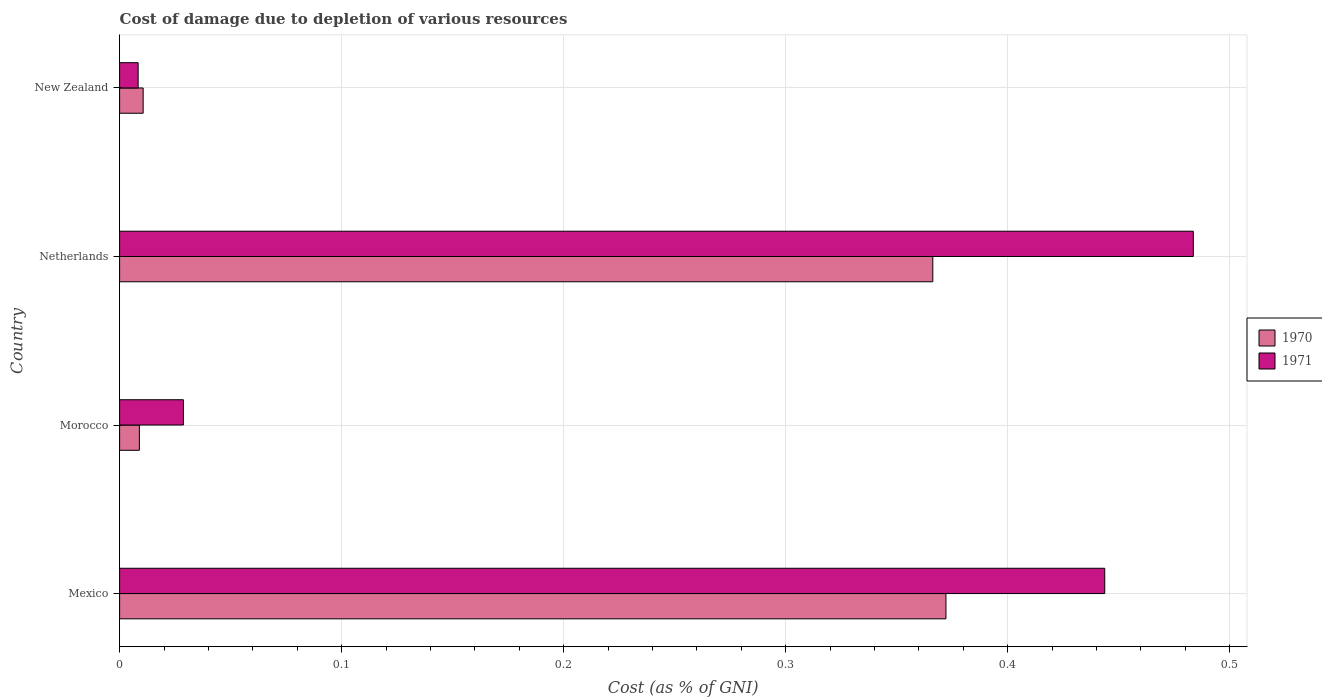How many different coloured bars are there?
Give a very brief answer. 2. How many groups of bars are there?
Provide a short and direct response. 4. Are the number of bars per tick equal to the number of legend labels?
Your answer should be very brief. Yes. Are the number of bars on each tick of the Y-axis equal?
Give a very brief answer. Yes. How many bars are there on the 1st tick from the bottom?
Give a very brief answer. 2. What is the cost of damage caused due to the depletion of various resources in 1971 in Netherlands?
Make the answer very short. 0.48. Across all countries, what is the maximum cost of damage caused due to the depletion of various resources in 1971?
Your answer should be very brief. 0.48. Across all countries, what is the minimum cost of damage caused due to the depletion of various resources in 1971?
Your answer should be compact. 0.01. In which country was the cost of damage caused due to the depletion of various resources in 1970 maximum?
Keep it short and to the point. Mexico. In which country was the cost of damage caused due to the depletion of various resources in 1970 minimum?
Offer a very short reply. Morocco. What is the total cost of damage caused due to the depletion of various resources in 1971 in the graph?
Provide a short and direct response. 0.96. What is the difference between the cost of damage caused due to the depletion of various resources in 1971 in Mexico and that in Netherlands?
Keep it short and to the point. -0.04. What is the difference between the cost of damage caused due to the depletion of various resources in 1970 in New Zealand and the cost of damage caused due to the depletion of various resources in 1971 in Morocco?
Provide a short and direct response. -0.02. What is the average cost of damage caused due to the depletion of various resources in 1970 per country?
Provide a short and direct response. 0.19. What is the difference between the cost of damage caused due to the depletion of various resources in 1971 and cost of damage caused due to the depletion of various resources in 1970 in New Zealand?
Your response must be concise. -0. In how many countries, is the cost of damage caused due to the depletion of various resources in 1970 greater than 0.34 %?
Offer a very short reply. 2. What is the ratio of the cost of damage caused due to the depletion of various resources in 1971 in Morocco to that in New Zealand?
Make the answer very short. 3.44. What is the difference between the highest and the second highest cost of damage caused due to the depletion of various resources in 1971?
Give a very brief answer. 0.04. What is the difference between the highest and the lowest cost of damage caused due to the depletion of various resources in 1971?
Your answer should be very brief. 0.48. In how many countries, is the cost of damage caused due to the depletion of various resources in 1971 greater than the average cost of damage caused due to the depletion of various resources in 1971 taken over all countries?
Provide a short and direct response. 2. Is the sum of the cost of damage caused due to the depletion of various resources in 1971 in Mexico and New Zealand greater than the maximum cost of damage caused due to the depletion of various resources in 1970 across all countries?
Your answer should be compact. Yes. What does the 1st bar from the bottom in New Zealand represents?
Provide a succinct answer. 1970. Are all the bars in the graph horizontal?
Your answer should be compact. Yes. How many countries are there in the graph?
Provide a short and direct response. 4. Are the values on the major ticks of X-axis written in scientific E-notation?
Your response must be concise. No. How many legend labels are there?
Ensure brevity in your answer.  2. What is the title of the graph?
Offer a terse response. Cost of damage due to depletion of various resources. Does "2010" appear as one of the legend labels in the graph?
Ensure brevity in your answer.  No. What is the label or title of the X-axis?
Your response must be concise. Cost (as % of GNI). What is the label or title of the Y-axis?
Offer a terse response. Country. What is the Cost (as % of GNI) in 1970 in Mexico?
Your answer should be very brief. 0.37. What is the Cost (as % of GNI) in 1971 in Mexico?
Ensure brevity in your answer.  0.44. What is the Cost (as % of GNI) of 1970 in Morocco?
Provide a succinct answer. 0.01. What is the Cost (as % of GNI) in 1971 in Morocco?
Your response must be concise. 0.03. What is the Cost (as % of GNI) of 1970 in Netherlands?
Offer a terse response. 0.37. What is the Cost (as % of GNI) in 1971 in Netherlands?
Make the answer very short. 0.48. What is the Cost (as % of GNI) in 1970 in New Zealand?
Ensure brevity in your answer.  0.01. What is the Cost (as % of GNI) of 1971 in New Zealand?
Provide a short and direct response. 0.01. Across all countries, what is the maximum Cost (as % of GNI) in 1970?
Make the answer very short. 0.37. Across all countries, what is the maximum Cost (as % of GNI) in 1971?
Give a very brief answer. 0.48. Across all countries, what is the minimum Cost (as % of GNI) in 1970?
Provide a succinct answer. 0.01. Across all countries, what is the minimum Cost (as % of GNI) in 1971?
Offer a terse response. 0.01. What is the total Cost (as % of GNI) in 1970 in the graph?
Your response must be concise. 0.76. What is the total Cost (as % of GNI) in 1971 in the graph?
Provide a succinct answer. 0.96. What is the difference between the Cost (as % of GNI) in 1970 in Mexico and that in Morocco?
Your answer should be compact. 0.36. What is the difference between the Cost (as % of GNI) of 1971 in Mexico and that in Morocco?
Your answer should be compact. 0.41. What is the difference between the Cost (as % of GNI) of 1970 in Mexico and that in Netherlands?
Your response must be concise. 0.01. What is the difference between the Cost (as % of GNI) of 1971 in Mexico and that in Netherlands?
Ensure brevity in your answer.  -0.04. What is the difference between the Cost (as % of GNI) of 1970 in Mexico and that in New Zealand?
Your answer should be very brief. 0.36. What is the difference between the Cost (as % of GNI) of 1971 in Mexico and that in New Zealand?
Provide a short and direct response. 0.44. What is the difference between the Cost (as % of GNI) of 1970 in Morocco and that in Netherlands?
Make the answer very short. -0.36. What is the difference between the Cost (as % of GNI) in 1971 in Morocco and that in Netherlands?
Your answer should be compact. -0.45. What is the difference between the Cost (as % of GNI) in 1970 in Morocco and that in New Zealand?
Ensure brevity in your answer.  -0. What is the difference between the Cost (as % of GNI) of 1971 in Morocco and that in New Zealand?
Your answer should be very brief. 0.02. What is the difference between the Cost (as % of GNI) of 1970 in Netherlands and that in New Zealand?
Offer a terse response. 0.36. What is the difference between the Cost (as % of GNI) of 1971 in Netherlands and that in New Zealand?
Your response must be concise. 0.48. What is the difference between the Cost (as % of GNI) in 1970 in Mexico and the Cost (as % of GNI) in 1971 in Morocco?
Give a very brief answer. 0.34. What is the difference between the Cost (as % of GNI) in 1970 in Mexico and the Cost (as % of GNI) in 1971 in Netherlands?
Provide a short and direct response. -0.11. What is the difference between the Cost (as % of GNI) in 1970 in Mexico and the Cost (as % of GNI) in 1971 in New Zealand?
Offer a very short reply. 0.36. What is the difference between the Cost (as % of GNI) in 1970 in Morocco and the Cost (as % of GNI) in 1971 in Netherlands?
Provide a short and direct response. -0.47. What is the difference between the Cost (as % of GNI) of 1970 in Morocco and the Cost (as % of GNI) of 1971 in New Zealand?
Your answer should be compact. 0. What is the difference between the Cost (as % of GNI) of 1970 in Netherlands and the Cost (as % of GNI) of 1971 in New Zealand?
Ensure brevity in your answer.  0.36. What is the average Cost (as % of GNI) of 1970 per country?
Your answer should be very brief. 0.19. What is the average Cost (as % of GNI) in 1971 per country?
Provide a short and direct response. 0.24. What is the difference between the Cost (as % of GNI) of 1970 and Cost (as % of GNI) of 1971 in Mexico?
Your response must be concise. -0.07. What is the difference between the Cost (as % of GNI) of 1970 and Cost (as % of GNI) of 1971 in Morocco?
Provide a short and direct response. -0.02. What is the difference between the Cost (as % of GNI) of 1970 and Cost (as % of GNI) of 1971 in Netherlands?
Give a very brief answer. -0.12. What is the difference between the Cost (as % of GNI) in 1970 and Cost (as % of GNI) in 1971 in New Zealand?
Your response must be concise. 0. What is the ratio of the Cost (as % of GNI) in 1970 in Mexico to that in Morocco?
Offer a terse response. 41.78. What is the ratio of the Cost (as % of GNI) of 1971 in Mexico to that in Morocco?
Provide a succinct answer. 15.44. What is the ratio of the Cost (as % of GNI) in 1970 in Mexico to that in Netherlands?
Offer a terse response. 1.02. What is the ratio of the Cost (as % of GNI) of 1971 in Mexico to that in Netherlands?
Keep it short and to the point. 0.92. What is the ratio of the Cost (as % of GNI) in 1970 in Mexico to that in New Zealand?
Provide a short and direct response. 35.09. What is the ratio of the Cost (as % of GNI) in 1971 in Mexico to that in New Zealand?
Keep it short and to the point. 53.13. What is the ratio of the Cost (as % of GNI) of 1970 in Morocco to that in Netherlands?
Make the answer very short. 0.02. What is the ratio of the Cost (as % of GNI) of 1971 in Morocco to that in Netherlands?
Provide a short and direct response. 0.06. What is the ratio of the Cost (as % of GNI) in 1970 in Morocco to that in New Zealand?
Provide a short and direct response. 0.84. What is the ratio of the Cost (as % of GNI) in 1971 in Morocco to that in New Zealand?
Your answer should be compact. 3.44. What is the ratio of the Cost (as % of GNI) of 1970 in Netherlands to that in New Zealand?
Offer a very short reply. 34.53. What is the ratio of the Cost (as % of GNI) of 1971 in Netherlands to that in New Zealand?
Offer a very short reply. 57.9. What is the difference between the highest and the second highest Cost (as % of GNI) in 1970?
Make the answer very short. 0.01. What is the difference between the highest and the second highest Cost (as % of GNI) of 1971?
Your response must be concise. 0.04. What is the difference between the highest and the lowest Cost (as % of GNI) of 1970?
Offer a terse response. 0.36. What is the difference between the highest and the lowest Cost (as % of GNI) of 1971?
Your answer should be compact. 0.48. 